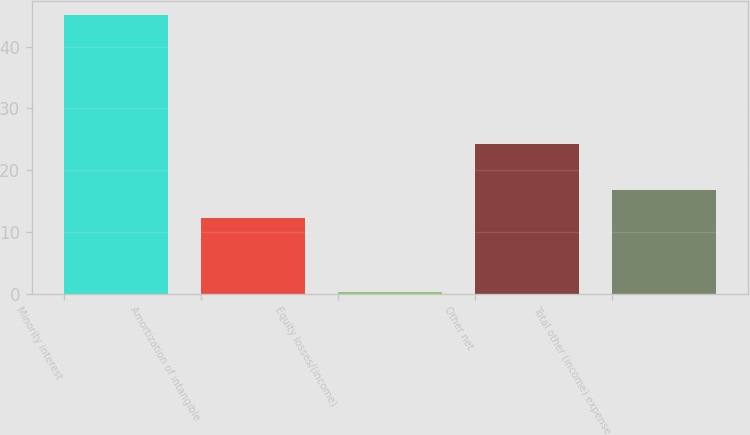Convert chart to OTSL. <chart><loc_0><loc_0><loc_500><loc_500><bar_chart><fcel>Minority interest<fcel>Amortization of intangible<fcel>Equity losses/(income)<fcel>Other net<fcel>Total other (income) expense<nl><fcel>45.2<fcel>12.3<fcel>0.3<fcel>24.3<fcel>16.79<nl></chart> 